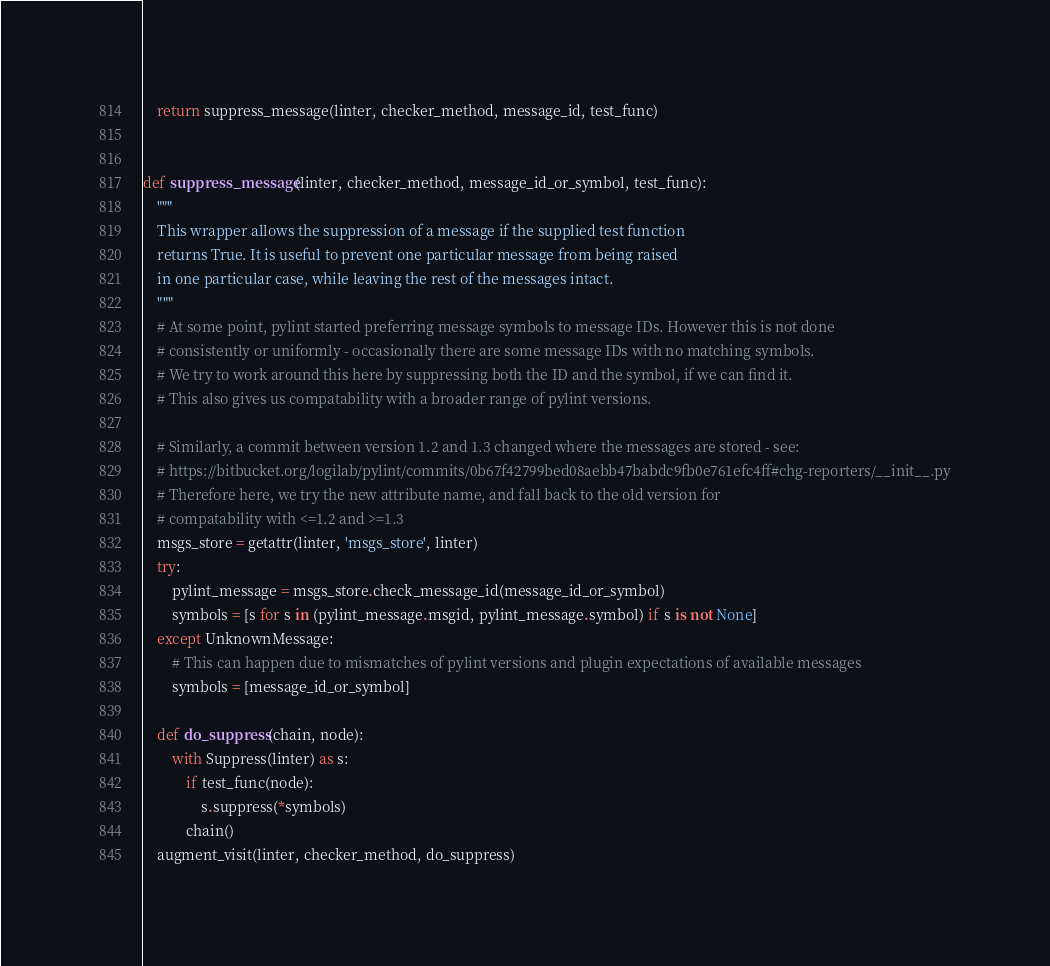<code> <loc_0><loc_0><loc_500><loc_500><_Python_>    return suppress_message(linter, checker_method, message_id, test_func)


def suppress_message(linter, checker_method, message_id_or_symbol, test_func):
    """
    This wrapper allows the suppression of a message if the supplied test function
    returns True. It is useful to prevent one particular message from being raised
    in one particular case, while leaving the rest of the messages intact.
    """
    # At some point, pylint started preferring message symbols to message IDs. However this is not done
    # consistently or uniformly - occasionally there are some message IDs with no matching symbols.
    # We try to work around this here by suppressing both the ID and the symbol, if we can find it.
    # This also gives us compatability with a broader range of pylint versions.

    # Similarly, a commit between version 1.2 and 1.3 changed where the messages are stored - see:
    # https://bitbucket.org/logilab/pylint/commits/0b67f42799bed08aebb47babdc9fb0e761efc4ff#chg-reporters/__init__.py
    # Therefore here, we try the new attribute name, and fall back to the old version for
    # compatability with <=1.2 and >=1.3
    msgs_store = getattr(linter, 'msgs_store', linter)
    try:
        pylint_message = msgs_store.check_message_id(message_id_or_symbol)
        symbols = [s for s in (pylint_message.msgid, pylint_message.symbol) if s is not None]
    except UnknownMessage:
        # This can happen due to mismatches of pylint versions and plugin expectations of available messages
        symbols = [message_id_or_symbol]

    def do_suppress(chain, node):
        with Suppress(linter) as s:
            if test_func(node):
                s.suppress(*symbols)
            chain()
    augment_visit(linter, checker_method, do_suppress)
</code> 